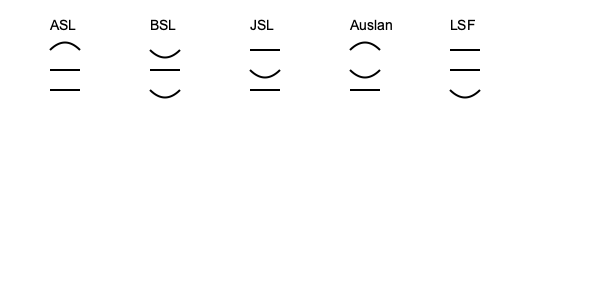Analyze the hand shape illustrations for five different sign languages shown above. Which two sign languages demonstrate the most similarity in their hand shape patterns, and what linguistic relationship might explain this similarity? To answer this question, we need to examine the hand shape patterns for each sign language and compare them:

1. ASL (American Sign Language): Curved, straight, straight
2. BSL (British Sign Language): Curved (opposite direction), straight, curved
3. JSL (Japanese Sign Language): Straight, curved, straight
4. Auslan (Australian Sign Language): Curved, curved (opposite direction), straight
5. LSF (French Sign Language): Straight, straight, curved

Step 1: Compare the patterns between all languages.
Step 2: Identify the two most similar patterns.
Step 3: Consider the historical and linguistic relationships between these languages.

The most similar patterns are between ASL and LSF. Both have two straight lines and one curved line, with only a difference in the position of the curved line.

This similarity can be explained by the historical relationship between American Sign Language and French Sign Language. ASL was developed in the early 19th century with significant influence from LSF. Laurent Clerc, a deaf French educator, came to the United States in 1816 to help establish the first school for the deaf in Hartford, Connecticut. He brought LSF with him, which then mixed with the local sign languages to form what became ASL.

This historical connection explains why ASL and LSF share many similarities in their hand shapes and movements, despite being used in different countries and evolving separately over time.
Answer: ASL and LSF; historical influence of LSF on ASL's development. 